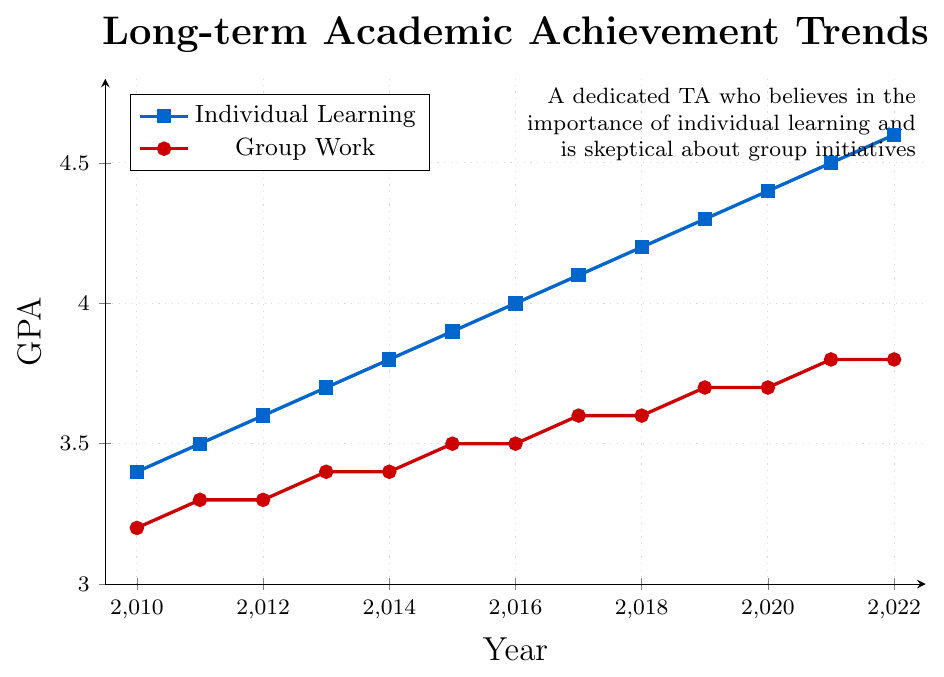What is the GPA for individual learning in 2016? To find the GPA for individual learning in 2016, locate the data point for the "Individual Learning" line at the year 2016 on the x-axis.
Answer: 4.0 Which year shows the highest GPA for group work? By inspecting the "Group Work" line, observe the year with the highest data point.
Answer: 2022 What is the difference in GPA between individual learning and group work in 2010? Subtract the GPA for group work from the GPA for individual learning for the year 2010.
Answer: 0.2 What is the average GPA for individual learning between 2010 and 2012? Add the GPAs for individual learning from 2010 (3.4), 2011 (3.5), and 2012 (3.6), and then divide by 3.
Answer: 3.5 Is there a year when the GPAs for individual learning and group work are equal? Compare the data points of both lines for each year to see if they align.
Answer: No In which year does the gap between individual learning GPA and group work GPA seem to be the largest? Look for the largest vertical distance between the "Individual Learning" and "Group Work" lines.
Answer: 2022 How much did the GPA for group work increase from 2015 to 2020? Subtract the GPA for group work in 2015 (3.5) from the GPA for group work in 2020 (3.7).
Answer: 0.2 What trend do you observe for individual learning GPAs from 2010 to 2022? Observe the general direction of the "Individual Learning" line from 2010 to 2022.
Answer: Increasing Between 2017 and 2018, which group's GPA had no change? Compare the slopes of the lines for each group between these years; the line without a slope indicates no change.
Answer: Group Work What is the median GPA for the group work category over the years displayed? List all GPAs for group work, order them, and find the middle value: 3.2, 3.3, 3.3, 3.4, 3.4, 3.5, 3.5, 3.6, 3.6, 3.7, 3.7, 3.8, 3.8. The middle values are 3.5 and 3.5, so the median is (3.5 + 3.5) / 2.
Answer: 3.5 